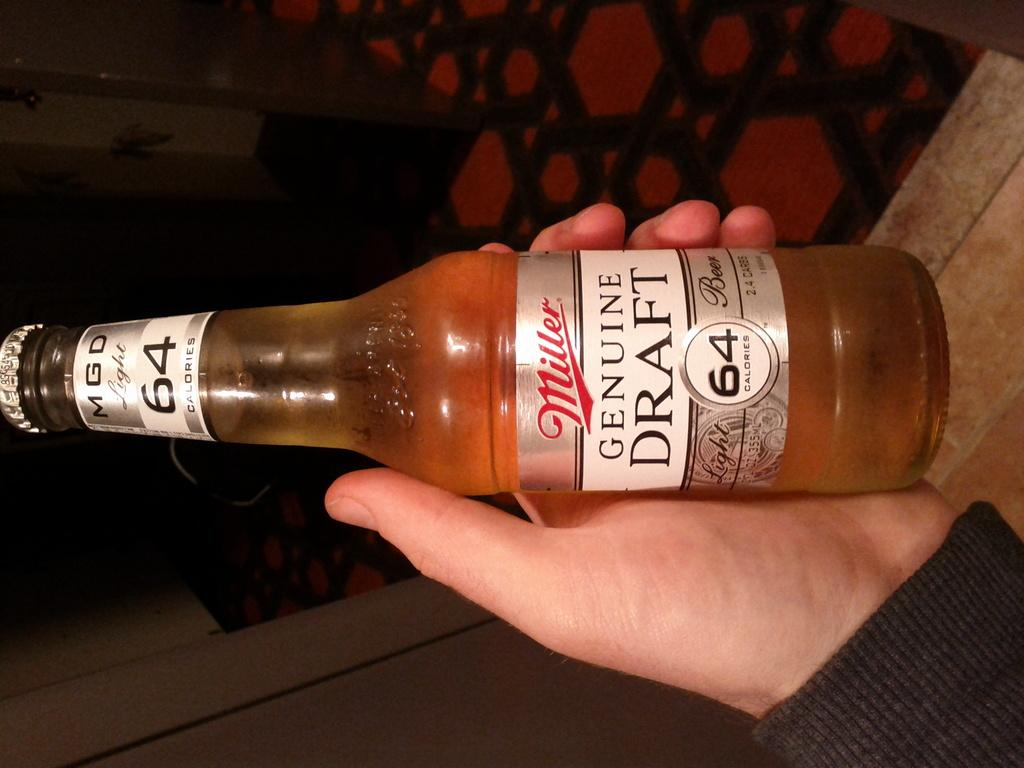<image>
Provide a brief description of the given image. Someone is holding a bottle of Miller Genuine Draft, which has the number 64 on the label. 